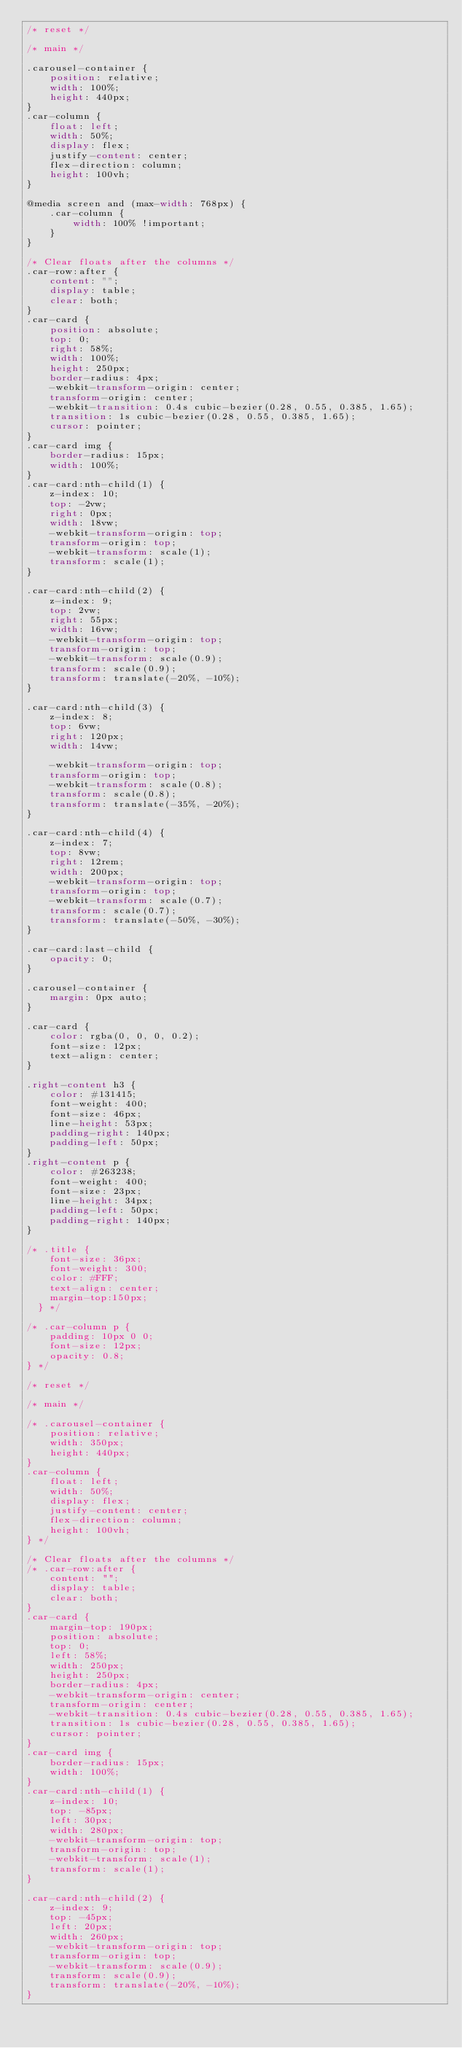Convert code to text. <code><loc_0><loc_0><loc_500><loc_500><_CSS_>/* reset */

/* main */

.carousel-container {
    position: relative;
    width: 100%;
    height: 440px;
}
.car-column {
    float: left;
    width: 50%;
    display: flex;
    justify-content: center;
    flex-direction: column;
    height: 100vh;
}

@media screen and (max-width: 768px) {
    .car-column {
        width: 100% !important;
    }
}

/* Clear floats after the columns */
.car-row:after {
    content: "";
    display: table;
    clear: both;
}
.car-card {
    position: absolute;
    top: 0;
    right: 58%;
    width: 100%;
    height: 250px;
    border-radius: 4px;
    -webkit-transform-origin: center;
    transform-origin: center;
    -webkit-transition: 0.4s cubic-bezier(0.28, 0.55, 0.385, 1.65);
    transition: 1s cubic-bezier(0.28, 0.55, 0.385, 1.65);
    cursor: pointer;
}
.car-card img {
    border-radius: 15px;
    width: 100%;
}
.car-card:nth-child(1) {
    z-index: 10;
    top: -2vw;
    right: 0px;
    width: 18vw;
    -webkit-transform-origin: top;
    transform-origin: top;
    -webkit-transform: scale(1);
    transform: scale(1);
}

.car-card:nth-child(2) {
    z-index: 9;
    top: 2vw;
    right: 55px;
    width: 16vw;
    -webkit-transform-origin: top;
    transform-origin: top;
    -webkit-transform: scale(0.9);
    transform: scale(0.9);
    transform: translate(-20%, -10%);
}

.car-card:nth-child(3) {
    z-index: 8;
    top: 6vw;
    right: 120px;
    width: 14vw;

    -webkit-transform-origin: top;
    transform-origin: top;
    -webkit-transform: scale(0.8);
    transform: scale(0.8);
    transform: translate(-35%, -20%);
}

.car-card:nth-child(4) {
    z-index: 7;
    top: 8vw;
    right: 12rem;
    width: 200px;
    -webkit-transform-origin: top;
    transform-origin: top;
    -webkit-transform: scale(0.7);
    transform: scale(0.7);
    transform: translate(-50%, -30%);
}

.car-card:last-child {
    opacity: 0;
}

.carousel-container {
    margin: 0px auto;
}

.car-card {
    color: rgba(0, 0, 0, 0.2);
    font-size: 12px;
    text-align: center;
}

.right-content h3 {
    color: #131415;
    font-weight: 400;
    font-size: 46px;
    line-height: 53px;
    padding-right: 140px;
    padding-left: 50px;
}
.right-content p {
    color: #263238;
    font-weight: 400;
    font-size: 23px;
    line-height: 34px;
    padding-left: 50px;
    padding-right: 140px;
}

/* .title {
    font-size: 36px;
    font-weight: 300;
    color: #FFF;
    text-align: center;
    margin-top:150px;
  } */

/* .car-column p {
    padding: 10px 0 0;
    font-size: 12px;
    opacity: 0.8;
} */

/* reset */

/* main */

/* .carousel-container {
    position: relative;
    width: 350px;
    height: 440px;
}
.car-column {
    float: left;
    width: 50%;
    display: flex;
    justify-content: center;
    flex-direction: column;
    height: 100vh;
} */

/* Clear floats after the columns */
/* .car-row:after {
    content: "";
    display: table;
    clear: both;
}
.car-card {
    margin-top: 190px;
    position: absolute;
    top: 0;
    left: 58%;
    width: 250px;
    height: 250px;
    border-radius: 4px;
    -webkit-transform-origin: center;
    transform-origin: center;
    -webkit-transition: 0.4s cubic-bezier(0.28, 0.55, 0.385, 1.65);
    transition: 1s cubic-bezier(0.28, 0.55, 0.385, 1.65);
    cursor: pointer;
}
.car-card img {
    border-radius: 15px;
    width: 100%;
}
.car-card:nth-child(1) {
    z-index: 10;
    top: -85px;
    left: 30px;
    width: 280px;
    -webkit-transform-origin: top;
    transform-origin: top;
    -webkit-transform: scale(1);
    transform: scale(1);
}

.car-card:nth-child(2) {
    z-index: 9;
    top: -45px;
    left: 20px;
    width: 260px;
    -webkit-transform-origin: top;
    transform-origin: top;
    -webkit-transform: scale(0.9);
    transform: scale(0.9);
    transform: translate(-20%, -10%);
}
</code> 